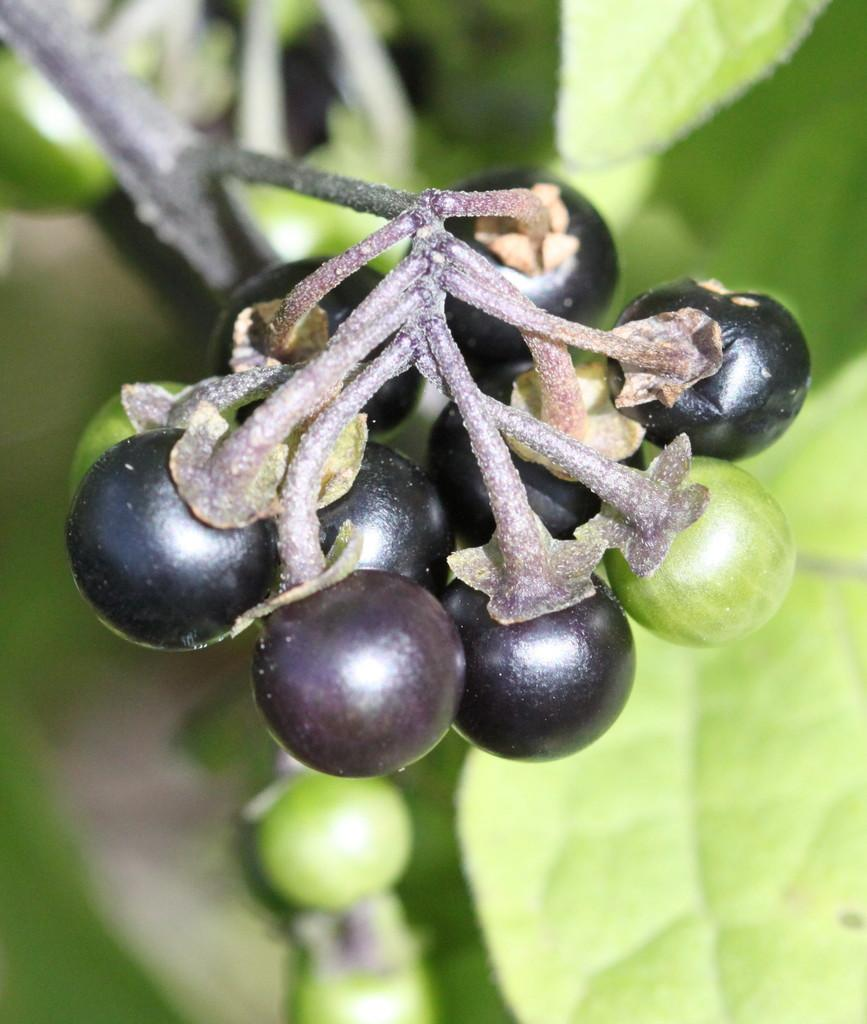What is the main subject of the image? The main subject of the image is a group of fruits. Where are the fruits located in the image? The fruits are on the stem of a plant. What type of protest is taking place in the image? There is no protest present in the image; it features a group of fruits on the stem of a plant. What color is the sweater worn by the fruit in the image? There is no fruit wearing a sweater in the image, as fruits do not wear clothing. 